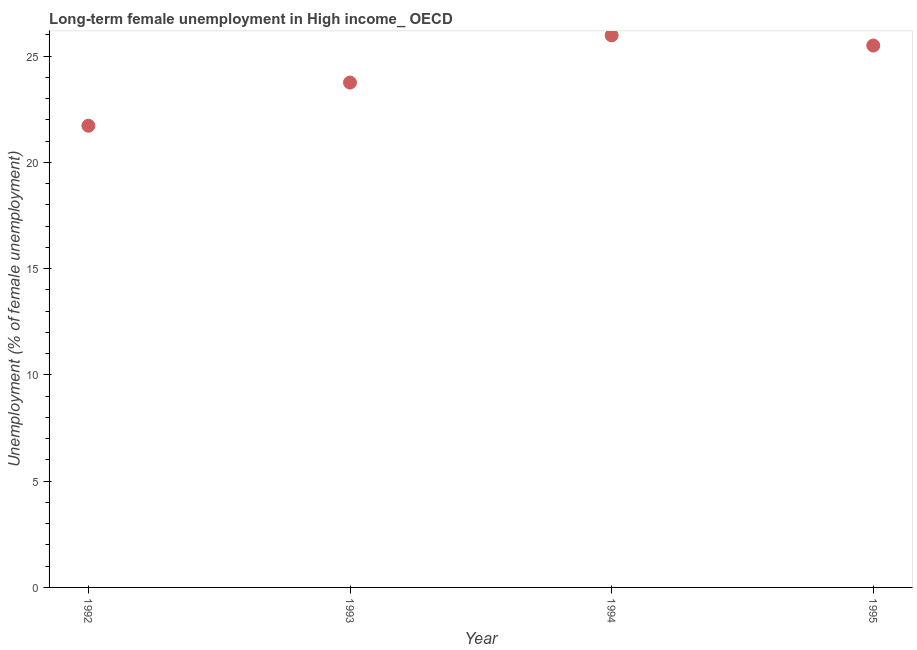What is the long-term female unemployment in 1995?
Your response must be concise. 25.49. Across all years, what is the maximum long-term female unemployment?
Offer a terse response. 25.97. Across all years, what is the minimum long-term female unemployment?
Your answer should be very brief. 21.72. What is the sum of the long-term female unemployment?
Offer a very short reply. 96.94. What is the difference between the long-term female unemployment in 1992 and 1993?
Your answer should be very brief. -2.03. What is the average long-term female unemployment per year?
Provide a short and direct response. 24.23. What is the median long-term female unemployment?
Provide a succinct answer. 24.62. Do a majority of the years between 1993 and 1994 (inclusive) have long-term female unemployment greater than 6 %?
Offer a terse response. Yes. What is the ratio of the long-term female unemployment in 1994 to that in 1995?
Offer a terse response. 1.02. Is the long-term female unemployment in 1992 less than that in 1994?
Keep it short and to the point. Yes. Is the difference between the long-term female unemployment in 1994 and 1995 greater than the difference between any two years?
Your answer should be very brief. No. What is the difference between the highest and the second highest long-term female unemployment?
Offer a terse response. 0.48. What is the difference between the highest and the lowest long-term female unemployment?
Offer a terse response. 4.25. Does the long-term female unemployment monotonically increase over the years?
Your answer should be compact. No. How many dotlines are there?
Make the answer very short. 1. Are the values on the major ticks of Y-axis written in scientific E-notation?
Give a very brief answer. No. Does the graph contain any zero values?
Ensure brevity in your answer.  No. Does the graph contain grids?
Make the answer very short. No. What is the title of the graph?
Make the answer very short. Long-term female unemployment in High income_ OECD. What is the label or title of the X-axis?
Your answer should be very brief. Year. What is the label or title of the Y-axis?
Your response must be concise. Unemployment (% of female unemployment). What is the Unemployment (% of female unemployment) in 1992?
Keep it short and to the point. 21.72. What is the Unemployment (% of female unemployment) in 1993?
Your answer should be very brief. 23.75. What is the Unemployment (% of female unemployment) in 1994?
Offer a terse response. 25.97. What is the Unemployment (% of female unemployment) in 1995?
Your response must be concise. 25.49. What is the difference between the Unemployment (% of female unemployment) in 1992 and 1993?
Give a very brief answer. -2.03. What is the difference between the Unemployment (% of female unemployment) in 1992 and 1994?
Offer a terse response. -4.25. What is the difference between the Unemployment (% of female unemployment) in 1992 and 1995?
Offer a very short reply. -3.77. What is the difference between the Unemployment (% of female unemployment) in 1993 and 1994?
Make the answer very short. -2.22. What is the difference between the Unemployment (% of female unemployment) in 1993 and 1995?
Your response must be concise. -1.74. What is the difference between the Unemployment (% of female unemployment) in 1994 and 1995?
Offer a very short reply. 0.48. What is the ratio of the Unemployment (% of female unemployment) in 1992 to that in 1993?
Provide a succinct answer. 0.92. What is the ratio of the Unemployment (% of female unemployment) in 1992 to that in 1994?
Ensure brevity in your answer.  0.84. What is the ratio of the Unemployment (% of female unemployment) in 1992 to that in 1995?
Offer a very short reply. 0.85. What is the ratio of the Unemployment (% of female unemployment) in 1993 to that in 1994?
Ensure brevity in your answer.  0.91. What is the ratio of the Unemployment (% of female unemployment) in 1993 to that in 1995?
Ensure brevity in your answer.  0.93. 